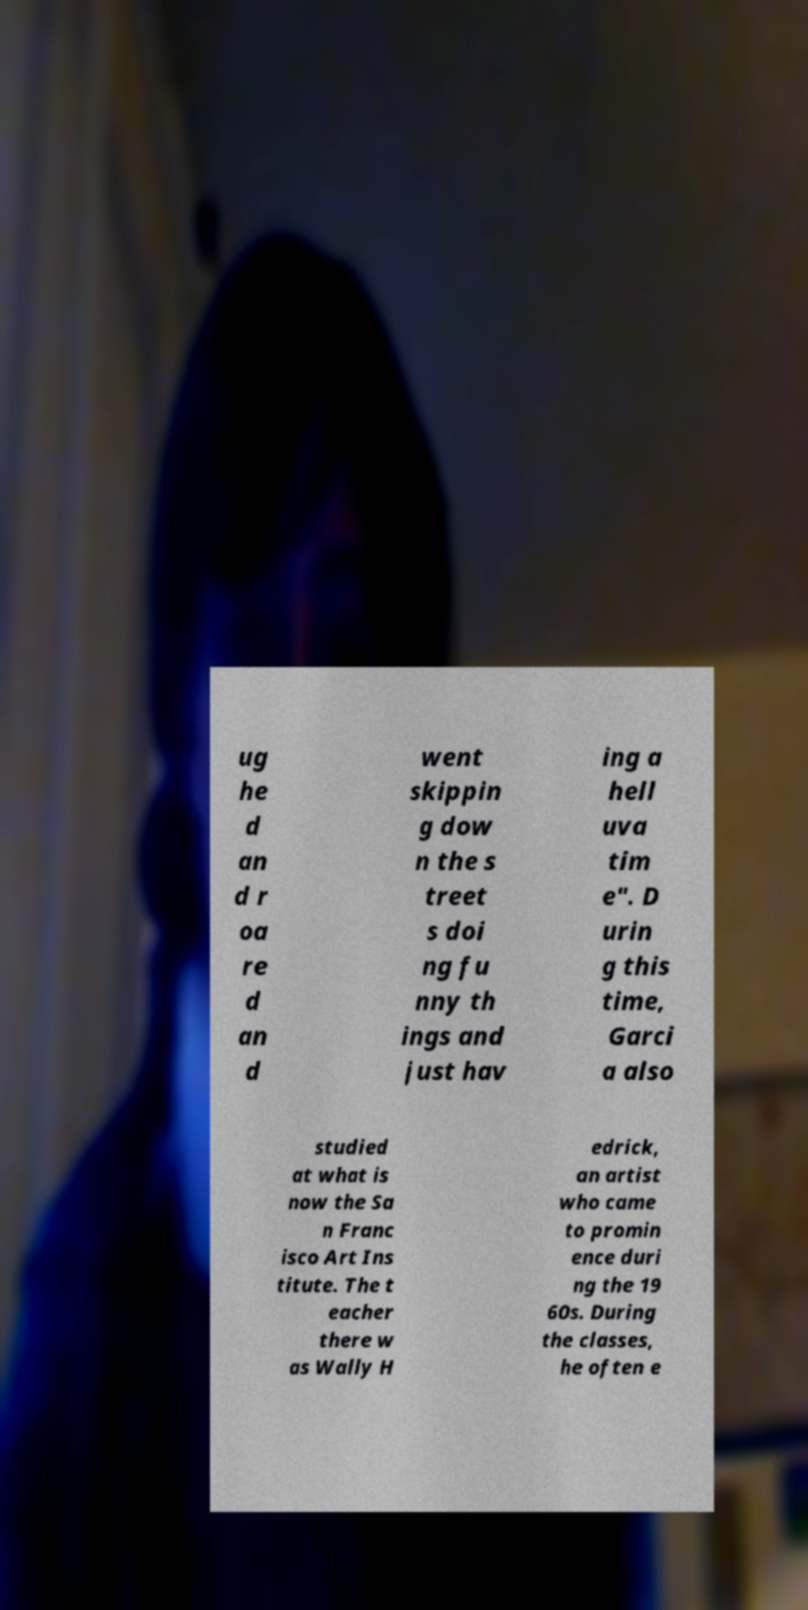For documentation purposes, I need the text within this image transcribed. Could you provide that? ug he d an d r oa re d an d went skippin g dow n the s treet s doi ng fu nny th ings and just hav ing a hell uva tim e". D urin g this time, Garci a also studied at what is now the Sa n Franc isco Art Ins titute. The t eacher there w as Wally H edrick, an artist who came to promin ence duri ng the 19 60s. During the classes, he often e 